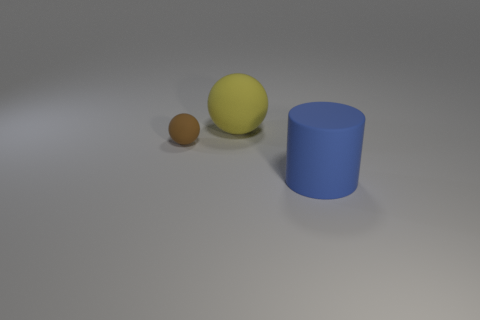What number of green shiny blocks have the same size as the blue rubber cylinder?
Offer a terse response. 0. There is another thing that is the same shape as the tiny brown object; what is its material?
Ensure brevity in your answer.  Rubber. There is a large rubber sphere on the right side of the small object; is its color the same as the large rubber thing that is in front of the big ball?
Your answer should be very brief. No. There is a rubber object on the right side of the yellow matte sphere; what shape is it?
Provide a succinct answer. Cylinder. The big ball has what color?
Your answer should be compact. Yellow. The blue object that is made of the same material as the small brown sphere is what shape?
Your answer should be compact. Cylinder. There is a ball on the left side of the yellow matte thing; is its size the same as the yellow thing?
Your response must be concise. No. What number of things are either rubber things behind the brown object or big rubber things that are behind the large matte cylinder?
Provide a succinct answer. 1. Does the large thing on the right side of the big yellow matte thing have the same color as the tiny rubber ball?
Provide a succinct answer. No. How many matte things are either brown objects or large cyan cylinders?
Make the answer very short. 1. 